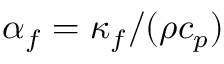Convert formula to latex. <formula><loc_0><loc_0><loc_500><loc_500>\alpha _ { f } = \kappa _ { f } / ( \rho c _ { p } )</formula> 